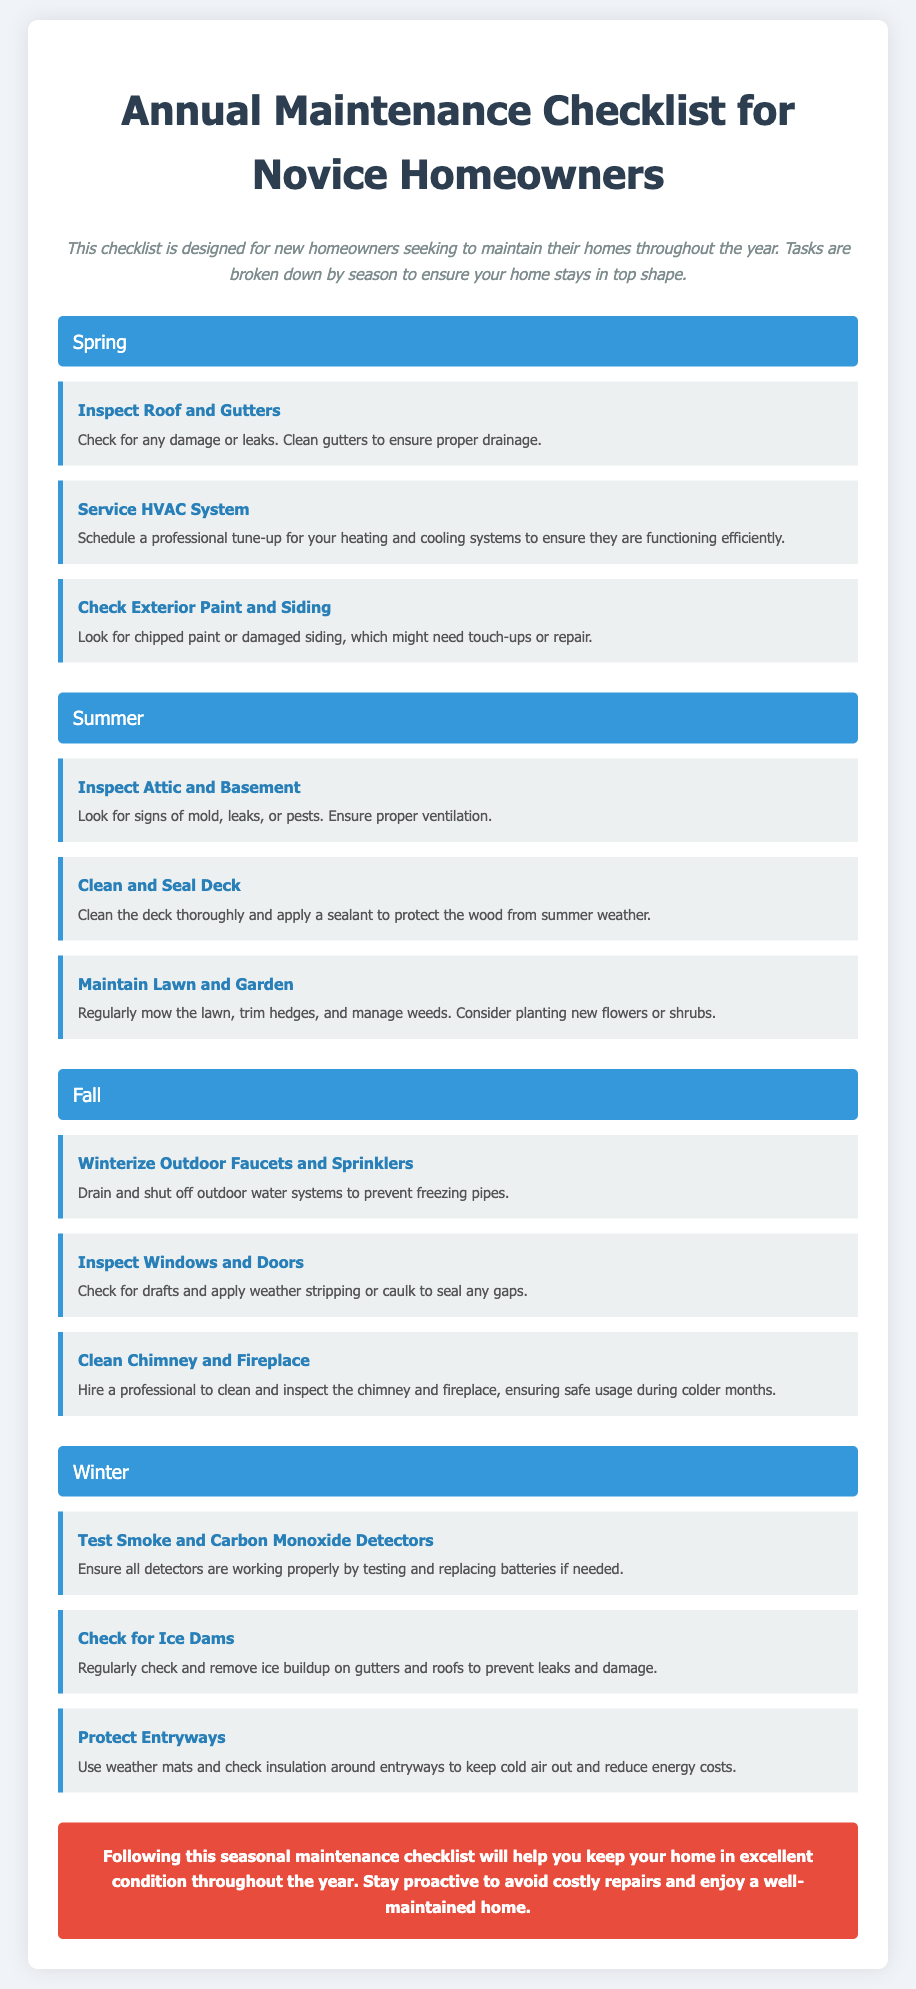what is the title of the document? The title of the document is mentioned in the heading at the top, which is "Annual Maintenance Checklist for Novice Homeowners."
Answer: Annual Maintenance Checklist for Novice Homeowners how many seasons are listed in the document? The document has four distinct sections, each representing a season, which are Spring, Summer, Fall, and Winter.
Answer: Four what task should be done in Spring? The document lists several tasks under Spring, one example is "Inspect Roof and Gutters."
Answer: Inspect Roof and Gutters what is the purpose of the checklist? The purpose of the checklist is provided in the introductory paragraph explaining it is for new homeowners to maintain their homes.
Answer: Maintain homes which task involves outdoor water systems? One task related to outdoor water systems is "Winterize Outdoor Faucets and Sprinklers."
Answer: Winterize Outdoor Faucets and Sprinklers what is the conclusion about the maintenance checklist? The conclusion emphasizes the importance of following the checklist to keep the home in excellent condition.
Answer: Keep home in excellent condition how should the deck be maintained in summer? The document specifies that the deck should be "Clean and Seal Deck."
Answer: Clean and Seal Deck what type of detectors should be tested in winter? The task indicates that both "Smoke and Carbon Monoxide Detectors" should be tested.
Answer: Smoke and Carbon Monoxide Detectors 